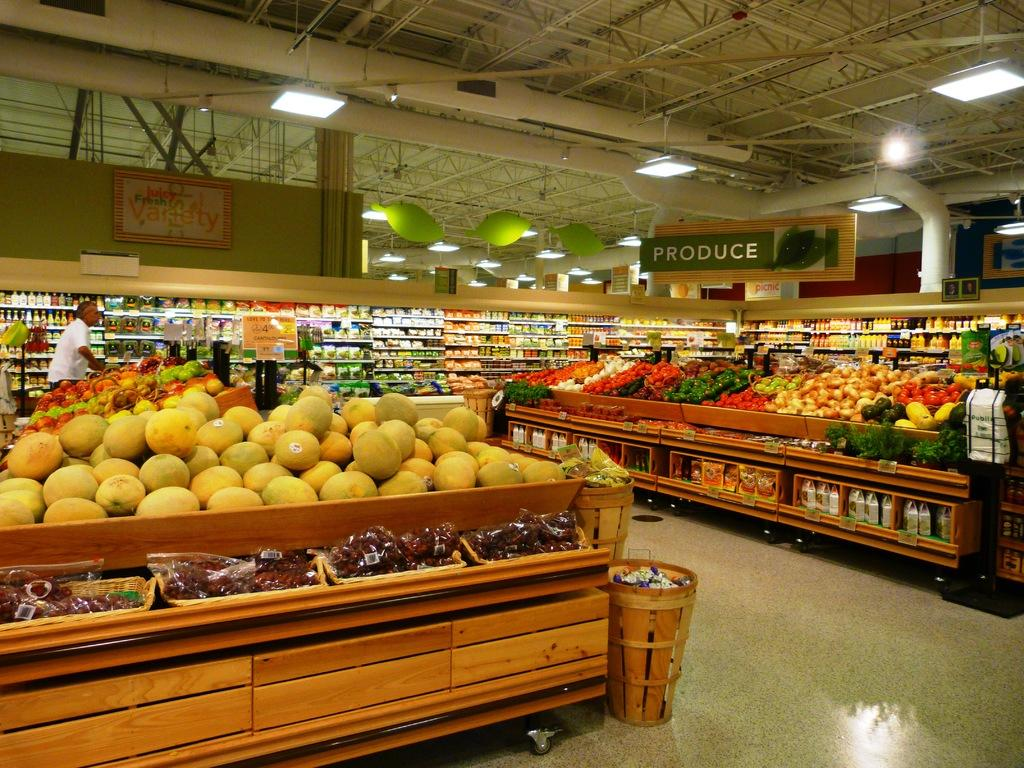<image>
Share a concise interpretation of the image provided. A grocery store full of produce with a sign above it. 